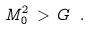<formula> <loc_0><loc_0><loc_500><loc_500>M _ { 0 } ^ { 2 } \, > \, G \ .</formula> 